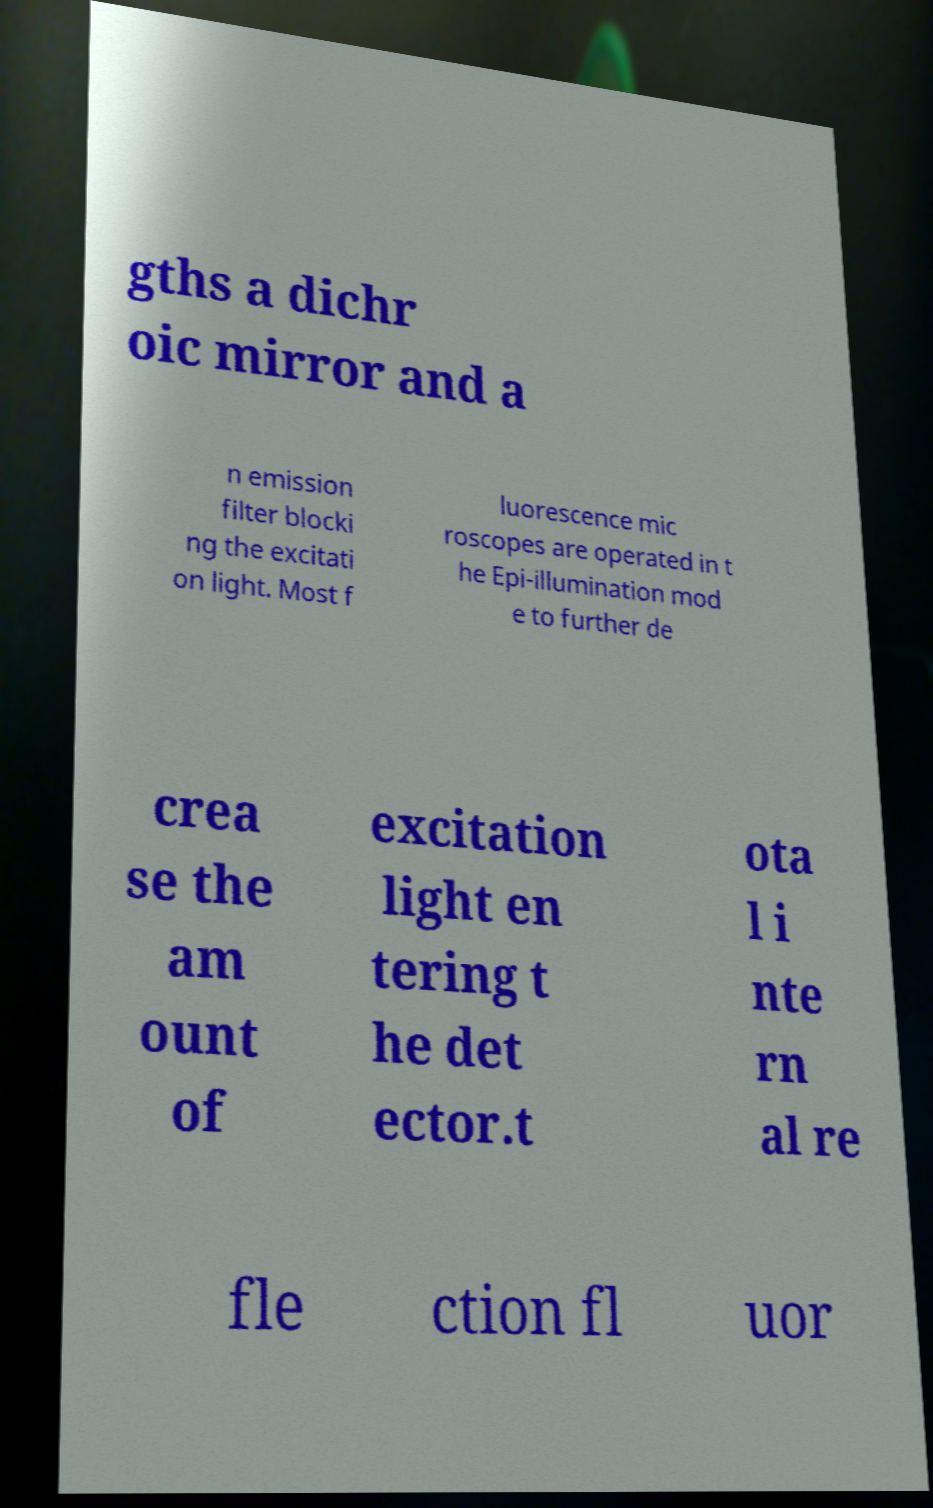Can you read and provide the text displayed in the image?This photo seems to have some interesting text. Can you extract and type it out for me? gths a dichr oic mirror and a n emission filter blocki ng the excitati on light. Most f luorescence mic roscopes are operated in t he Epi-illumination mod e to further de crea se the am ount of excitation light en tering t he det ector.t ota l i nte rn al re fle ction fl uor 